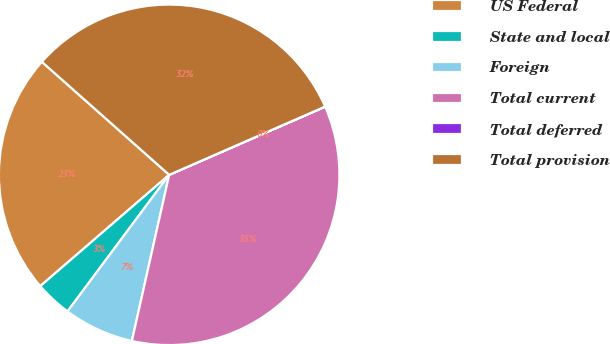Convert chart. <chart><loc_0><loc_0><loc_500><loc_500><pie_chart><fcel>US Federal<fcel>State and local<fcel>Foreign<fcel>Total current<fcel>Total deferred<fcel>Total provision<nl><fcel>22.89%<fcel>3.48%<fcel>6.67%<fcel>35.07%<fcel>0.01%<fcel>31.88%<nl></chart> 